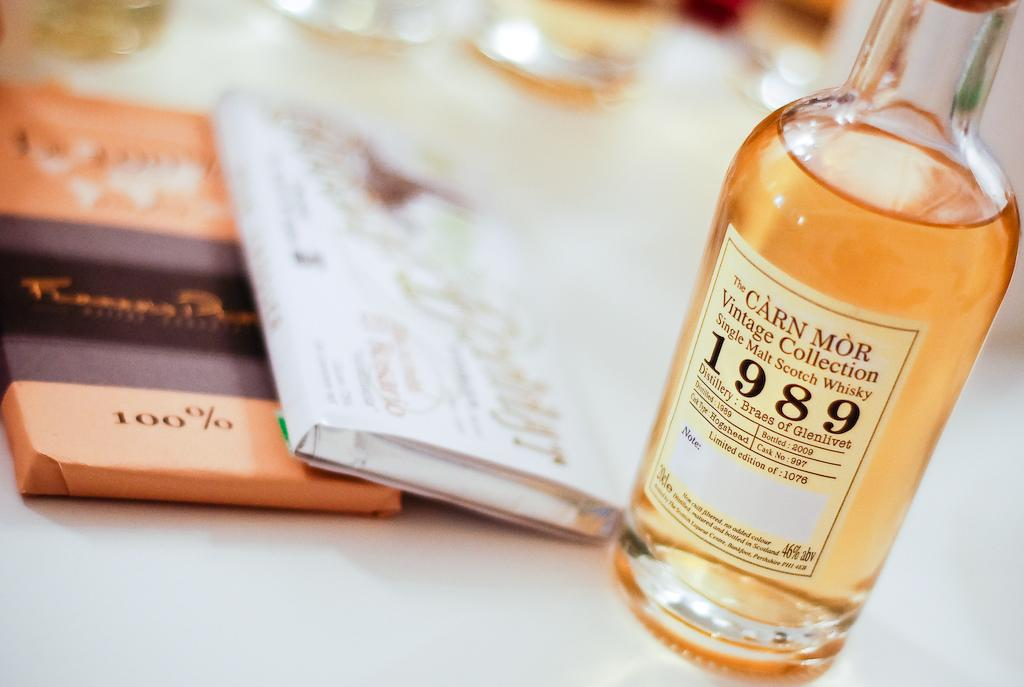<image>
Share a concise interpretation of the image provided. a 1989 bottle of the carn more vintage collection single malt scotch whisky 